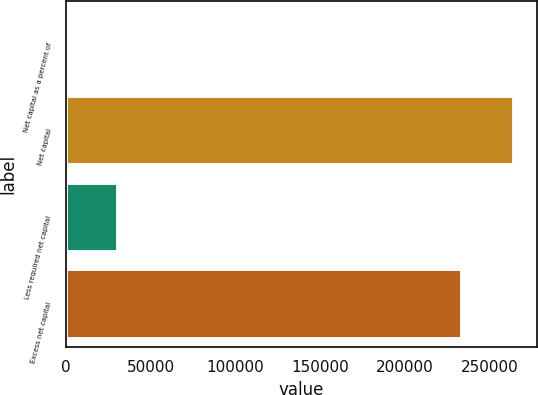<chart> <loc_0><loc_0><loc_500><loc_500><bar_chart><fcel>Net capital as a percent of<fcel>Net capital<fcel>Less required net capital<fcel>Excess net capital<nl><fcel>17.22<fcel>264315<fcel>30696<fcel>233619<nl></chart> 